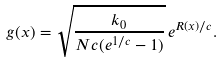Convert formula to latex. <formula><loc_0><loc_0><loc_500><loc_500>g ( x ) = \sqrt { \frac { k _ { 0 } } { N c ( e ^ { 1 / c } - 1 ) } } \, e ^ { R ( x ) / c } .</formula> 